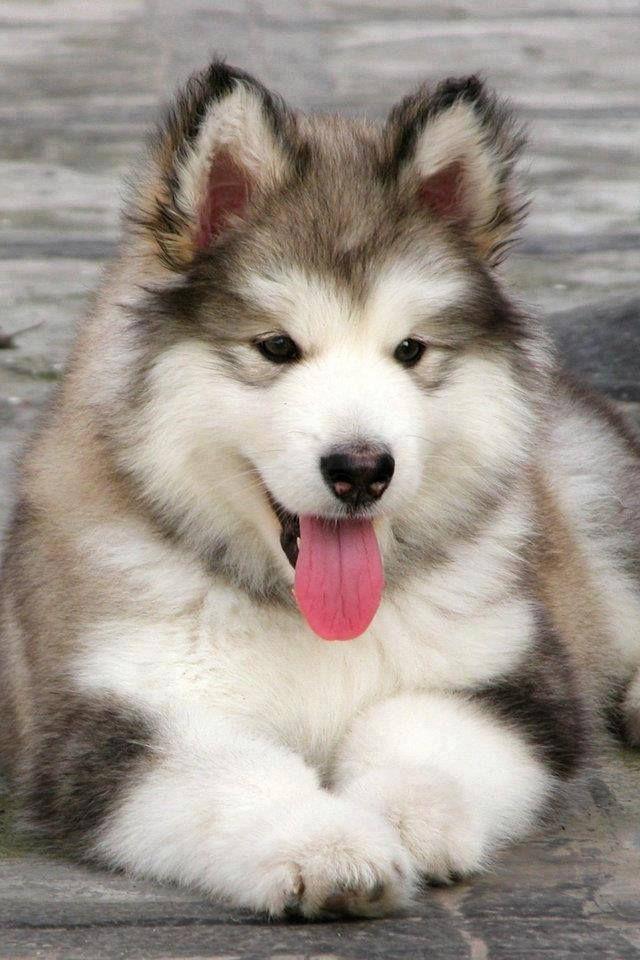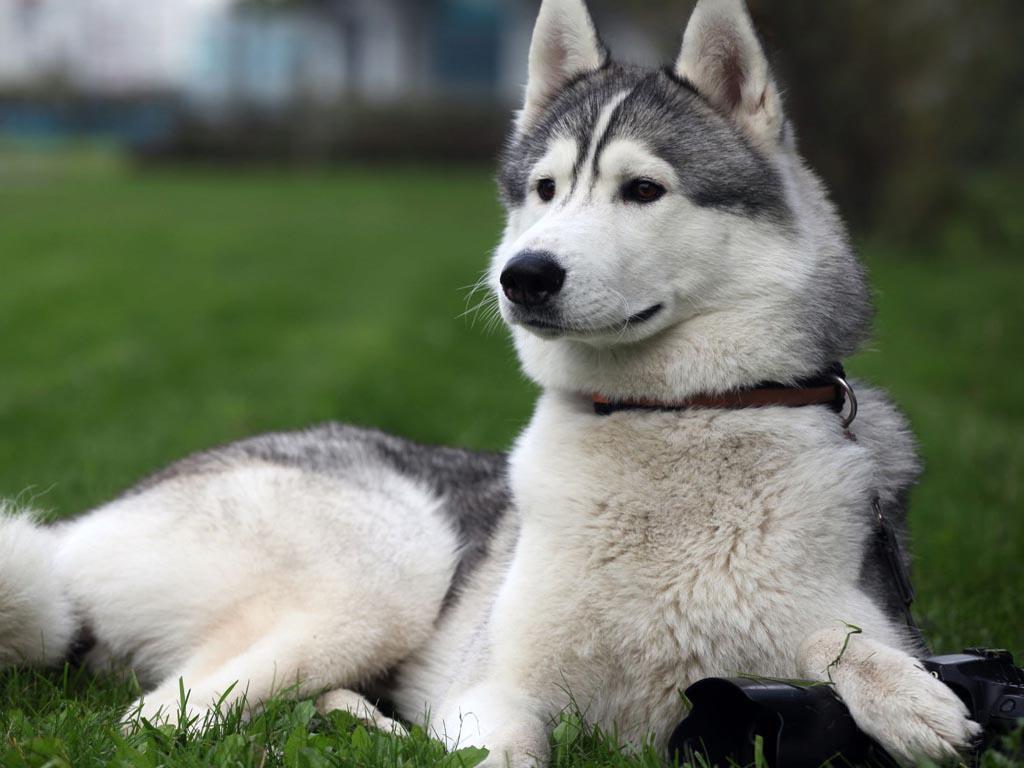The first image is the image on the left, the second image is the image on the right. Given the left and right images, does the statement "There are exactly two dogs." hold true? Answer yes or no. Yes. The first image is the image on the left, the second image is the image on the right. For the images shown, is this caption "There are no more than 2 dogs." true? Answer yes or no. Yes. 